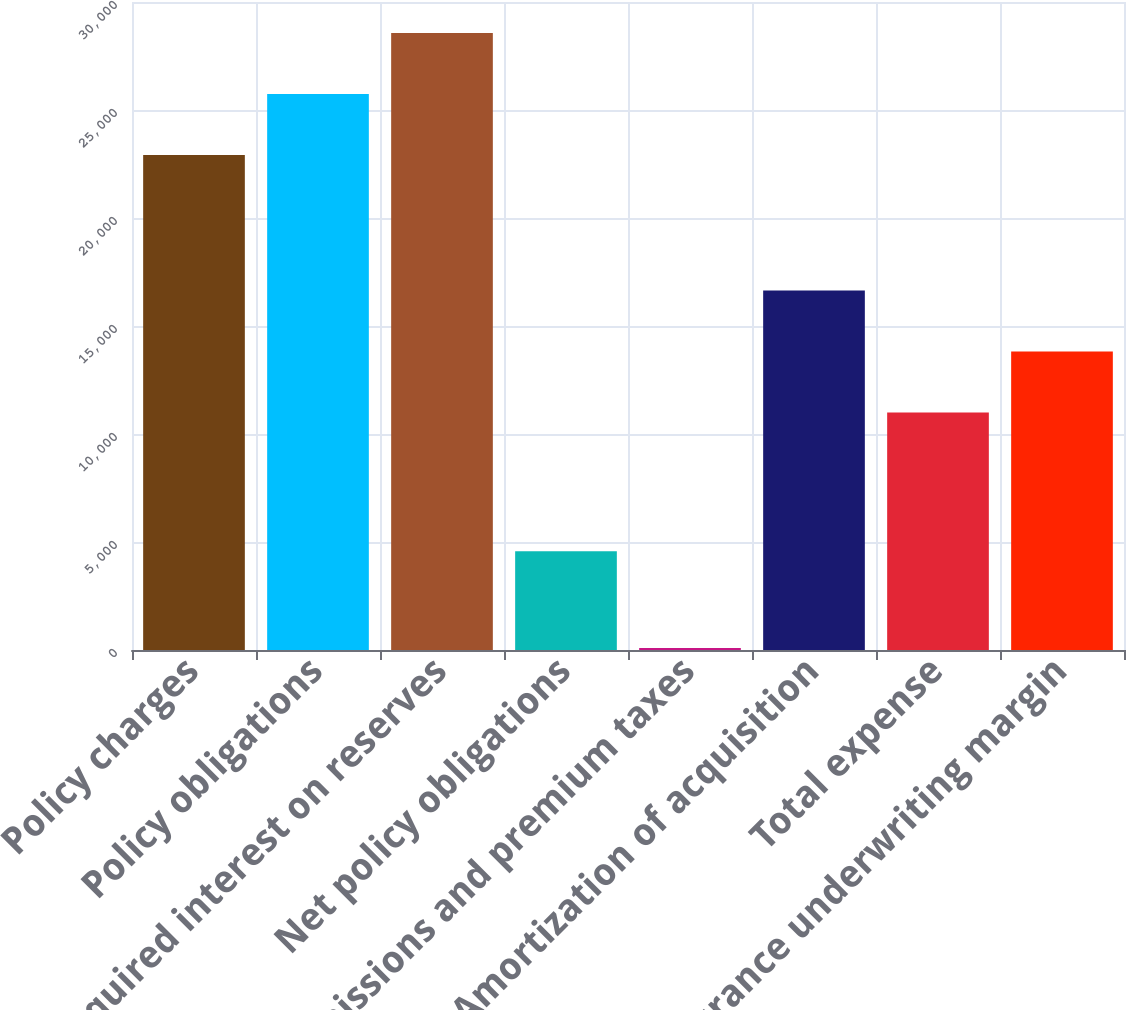<chart> <loc_0><loc_0><loc_500><loc_500><bar_chart><fcel>Policy charges<fcel>Policy obligations<fcel>Required interest on reserves<fcel>Net policy obligations<fcel>Commissions and premium taxes<fcel>Amortization of acquisition<fcel>Total expense<fcel>Insurance underwriting margin<nl><fcel>22914<fcel>25737<fcel>28560<fcel>4575<fcel>88<fcel>16645<fcel>10999<fcel>13822<nl></chart> 